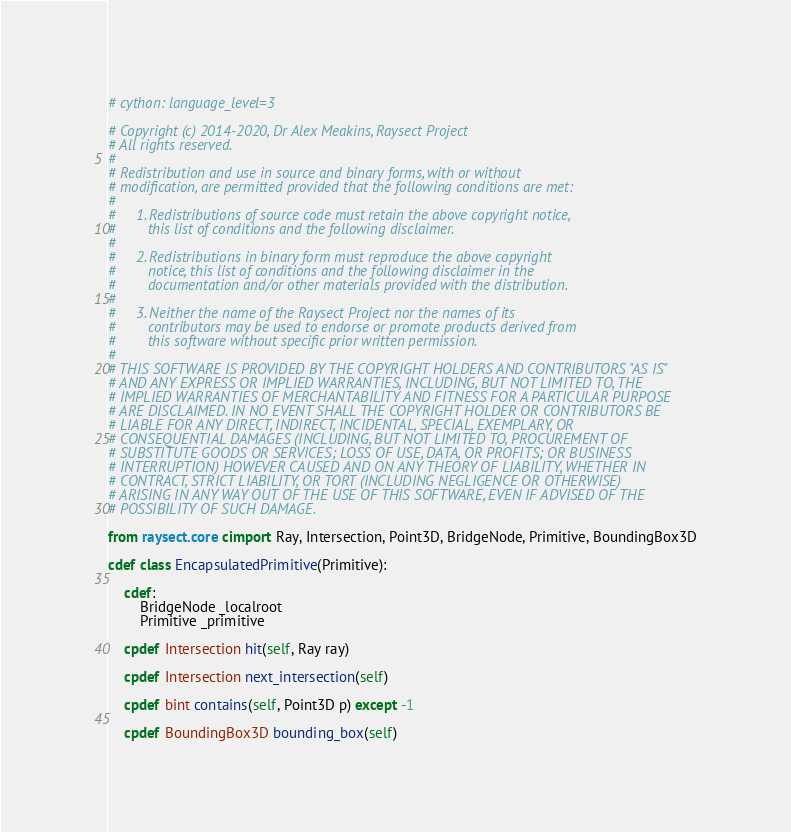<code> <loc_0><loc_0><loc_500><loc_500><_Cython_># cython: language_level=3

# Copyright (c) 2014-2020, Dr Alex Meakins, Raysect Project
# All rights reserved.
#
# Redistribution and use in source and binary forms, with or without
# modification, are permitted provided that the following conditions are met:
#
#     1. Redistributions of source code must retain the above copyright notice,
#        this list of conditions and the following disclaimer.
#
#     2. Redistributions in binary form must reproduce the above copyright
#        notice, this list of conditions and the following disclaimer in the
#        documentation and/or other materials provided with the distribution.
#
#     3. Neither the name of the Raysect Project nor the names of its
#        contributors may be used to endorse or promote products derived from
#        this software without specific prior written permission.
#
# THIS SOFTWARE IS PROVIDED BY THE COPYRIGHT HOLDERS AND CONTRIBUTORS "AS IS"
# AND ANY EXPRESS OR IMPLIED WARRANTIES, INCLUDING, BUT NOT LIMITED TO, THE
# IMPLIED WARRANTIES OF MERCHANTABILITY AND FITNESS FOR A PARTICULAR PURPOSE
# ARE DISCLAIMED. IN NO EVENT SHALL THE COPYRIGHT HOLDER OR CONTRIBUTORS BE
# LIABLE FOR ANY DIRECT, INDIRECT, INCIDENTAL, SPECIAL, EXEMPLARY, OR
# CONSEQUENTIAL DAMAGES (INCLUDING, BUT NOT LIMITED TO, PROCUREMENT OF
# SUBSTITUTE GOODS OR SERVICES; LOSS OF USE, DATA, OR PROFITS; OR BUSINESS
# INTERRUPTION) HOWEVER CAUSED AND ON ANY THEORY OF LIABILITY, WHETHER IN
# CONTRACT, STRICT LIABILITY, OR TORT (INCLUDING NEGLIGENCE OR OTHERWISE)
# ARISING IN ANY WAY OUT OF THE USE OF THIS SOFTWARE, EVEN IF ADVISED OF THE
# POSSIBILITY OF SUCH DAMAGE.

from raysect.core cimport Ray, Intersection, Point3D, BridgeNode, Primitive, BoundingBox3D

cdef class EncapsulatedPrimitive(Primitive):

    cdef:
        BridgeNode _localroot
        Primitive _primitive

    cpdef Intersection hit(self, Ray ray)

    cpdef Intersection next_intersection(self)

    cpdef bint contains(self, Point3D p) except -1

    cpdef BoundingBox3D bounding_box(self)
</code> 